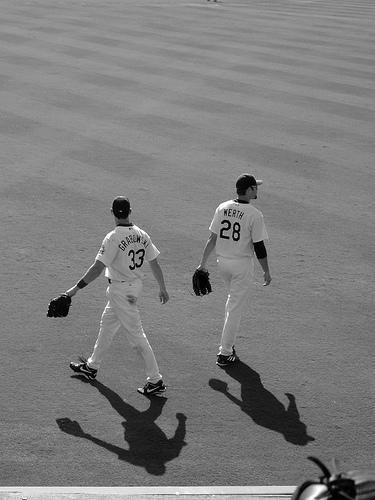How many people are in the photo?
Give a very brief answer. 2. 